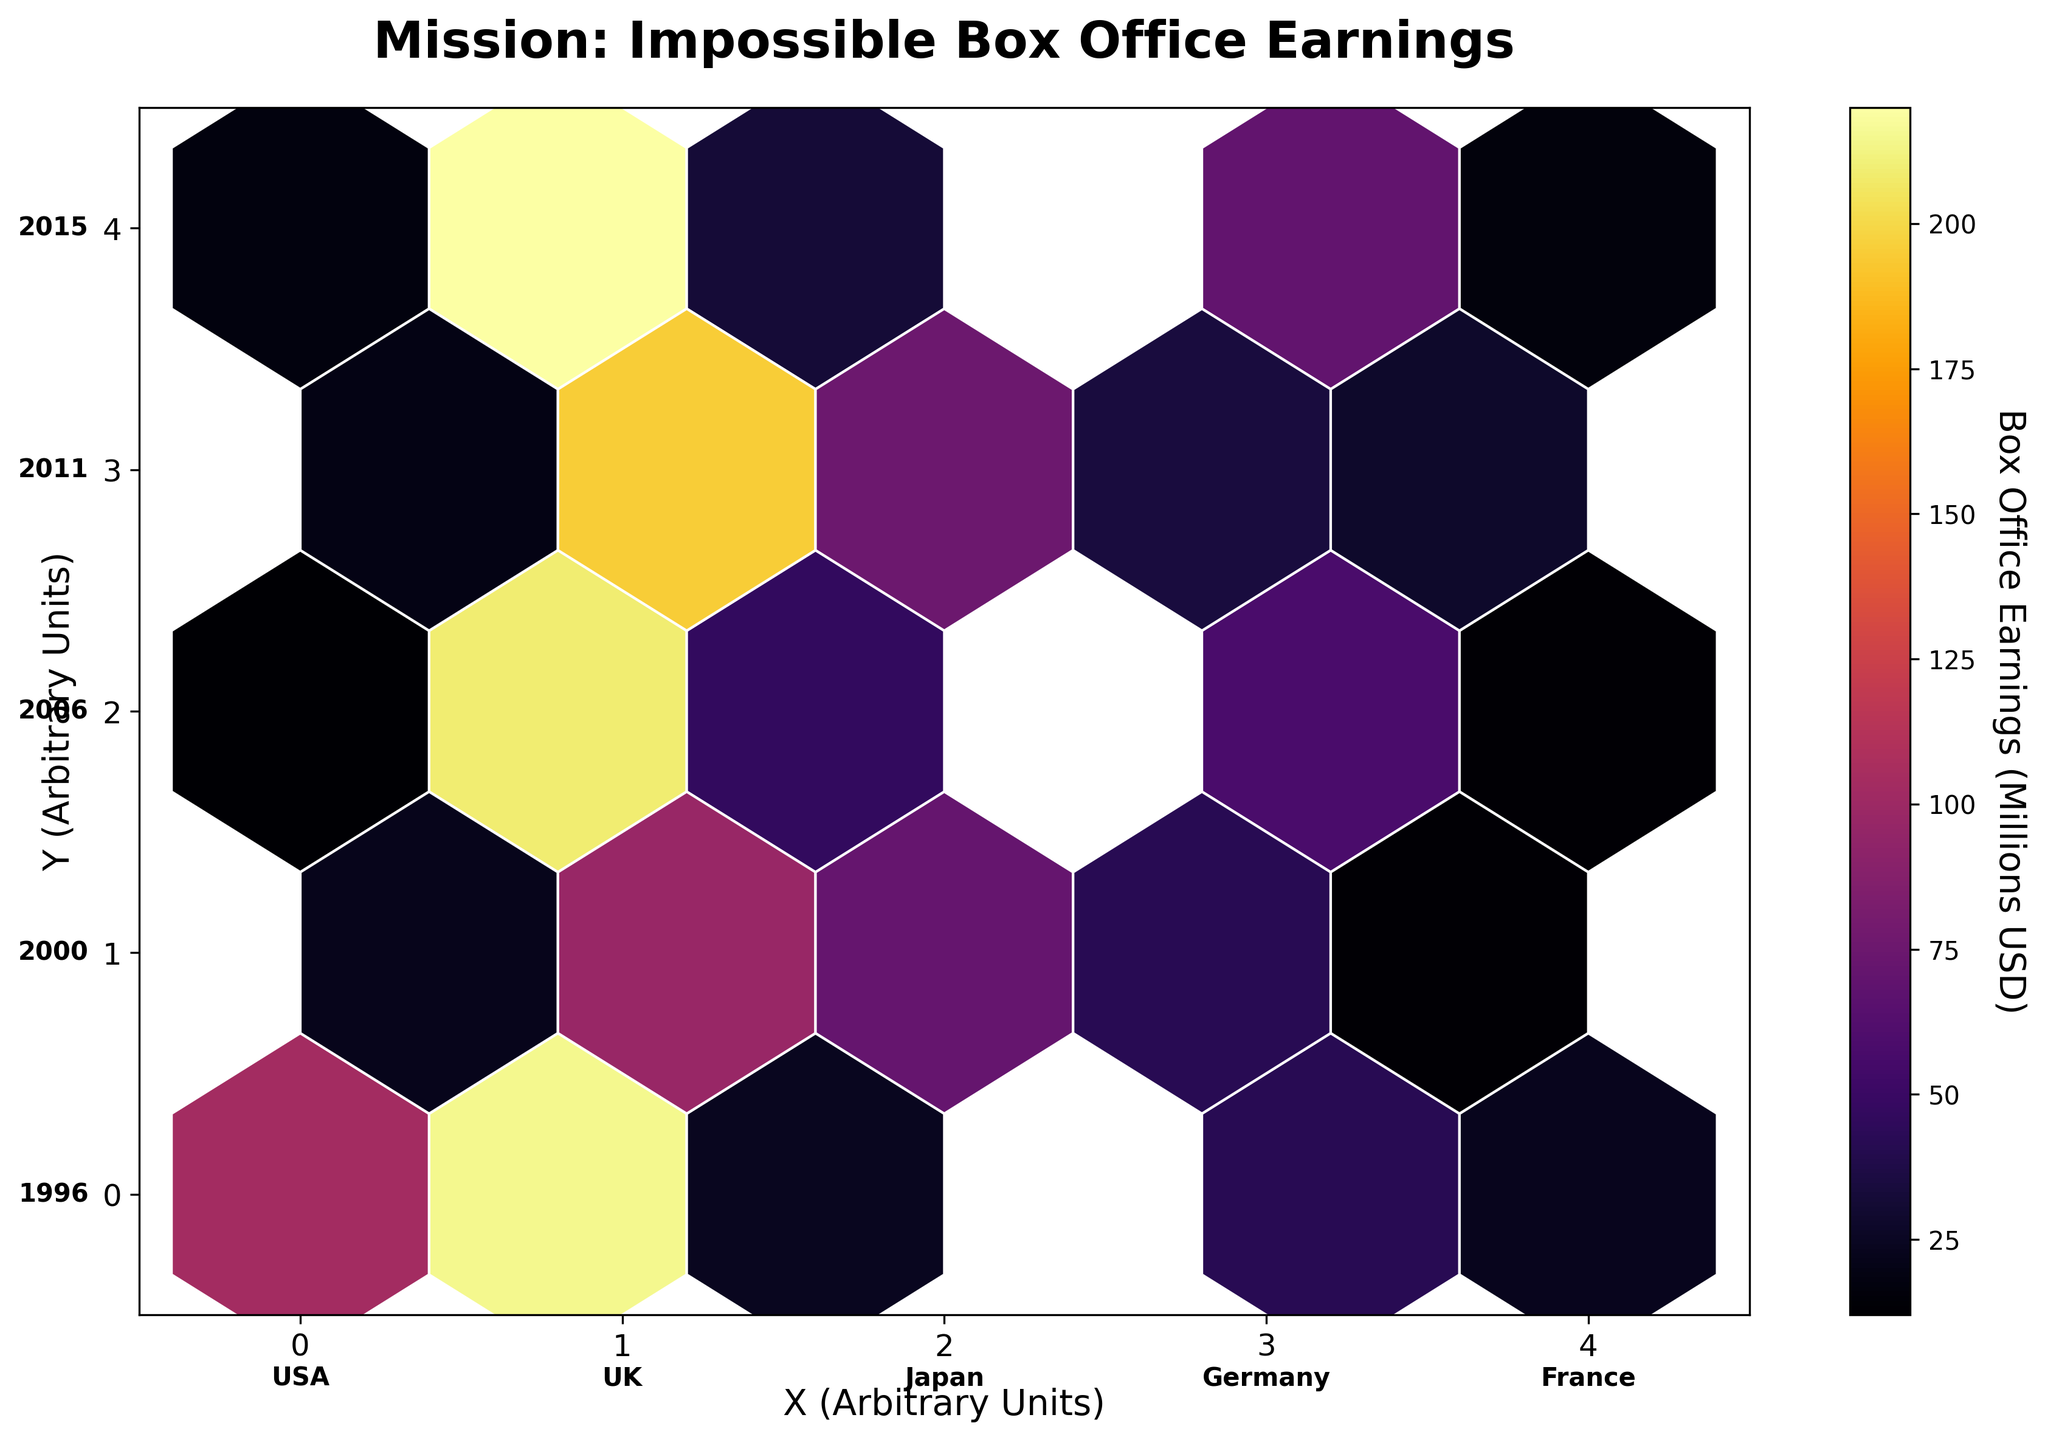What's the title of the plot? The title is displayed at the top center of the plot.
Answer: Mission: Impossible Box Office Earnings Which country corresponds to the hexagon at the bottom left corner of the plot? The bottom left corner is labeled with 'USA'.
Answer: USA What is the maximum box office earning represented in France? The hexagon positions in the plot show the countries and their box office earnings. The highest value in the hexagons corresponding to France (X positions 0, 4; Y positions 4, 0, etc.) can be visually compared.
Answer: 25 million USD How many countries are represented in the plot? The annotations at the bottom of the plot list all countries.
Answer: 5 Which release year shows the highest box office earnings for the USA? The box office value can be seen through the color intensity. The color bar helps to interpret this. Comparing hexagons in the row labeled 'USA' for different years (X position 1), the darkest hexagon corresponds to the highest value.
Answer: 2018 Between UK and Germany, which country has the highest box office earnings in 2011? Locate the hexagons at X positions 2 (UK) and 4 (Germany) in the Y position corresponding to 2011. The darker hexagon indicates higher earnings.
Answer: UK What is the average box office earning for Japan across all release dates? Summing the values from Japanese hexagons and dividing by the number of hexagons gives the average (52 + 58 + 44 + 70 + 42 + 42) / 6.
Answer: 51 million USD Which country has the lowest box office earnings for a Mission: Impossible movie in 2006, and how much is it? Identify the corresponding hexagons for each country in 2006 (Y position 2), and find the one with the lightest color.
Answer: France, 12 million USD Compare the box office earnings in 1996 and 2000 for Germany. Which year had higher earnings? Locate Germany hexagons for positions Y=0 (1996) and Y=1 (2000), then compare the darker color indicating higher value.
Answer: 2000 How does the box office earning trend for the UK change over the years from 1996 to 2018? By observing the changes in hexagon color intensity at position X=2 for each year from Y=0 to Y=4, the trend shows the variation in earnings over time.
Answer: Decreases, with peaks in certain years 